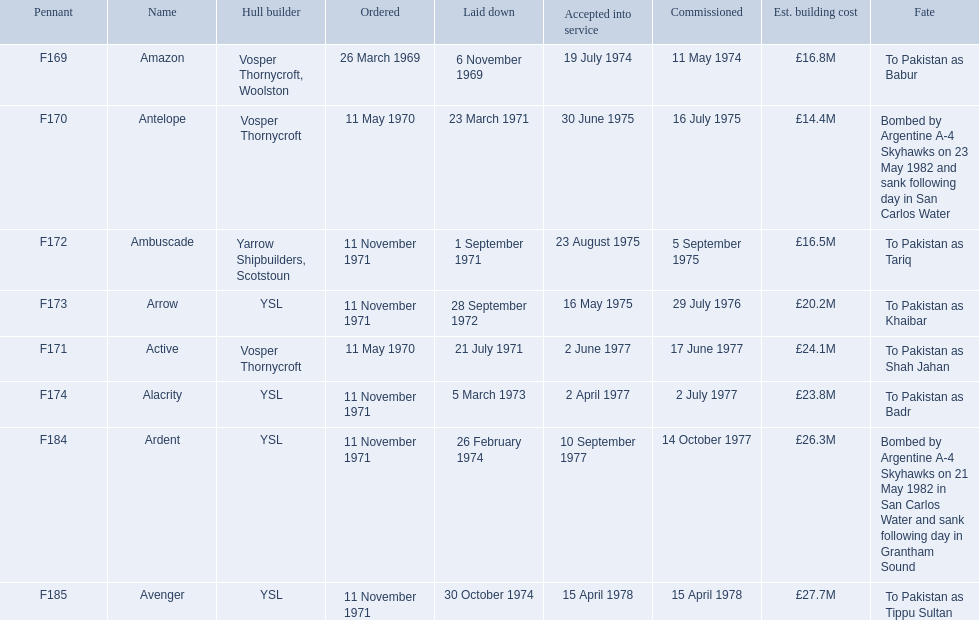Which ships cost more than ps25.0m to build? Ardent, Avenger. Of the ships listed in the answer above, which one cost the most to build? Avenger. 